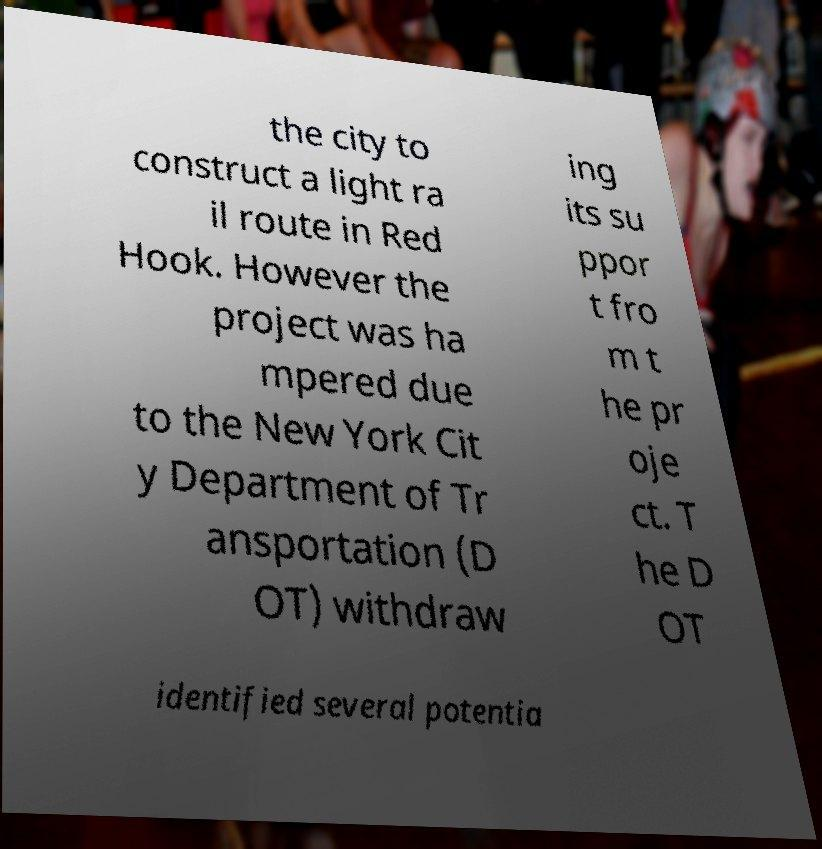Please read and relay the text visible in this image. What does it say? the city to construct a light ra il route in Red Hook. However the project was ha mpered due to the New York Cit y Department of Tr ansportation (D OT) withdraw ing its su ppor t fro m t he pr oje ct. T he D OT identified several potentia 